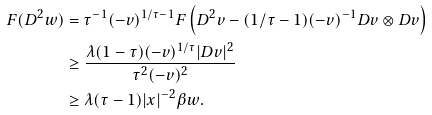<formula> <loc_0><loc_0><loc_500><loc_500>F ( D ^ { 2 } w ) & = \tau ^ { - 1 } ( - v ) ^ { 1 / \tau - 1 } F \left ( D ^ { 2 } v - ( 1 / \tau - 1 ) ( - v ) ^ { - 1 } D v \otimes D v \right ) \\ & \geq \frac { \lambda ( 1 - \tau ) ( - v ) ^ { 1 / \tau } | D v | ^ { 2 } } { \tau ^ { 2 } ( - v ) ^ { 2 } } \\ & \geq \lambda ( \tau - 1 ) | x | ^ { - 2 } \beta w .</formula> 